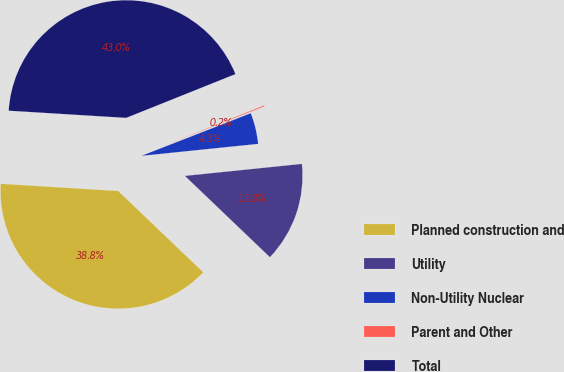Convert chart to OTSL. <chart><loc_0><loc_0><loc_500><loc_500><pie_chart><fcel>Planned construction and<fcel>Utility<fcel>Non-Utility Nuclear<fcel>Parent and Other<fcel>Total<nl><fcel>38.83%<fcel>13.77%<fcel>4.29%<fcel>0.15%<fcel>42.96%<nl></chart> 